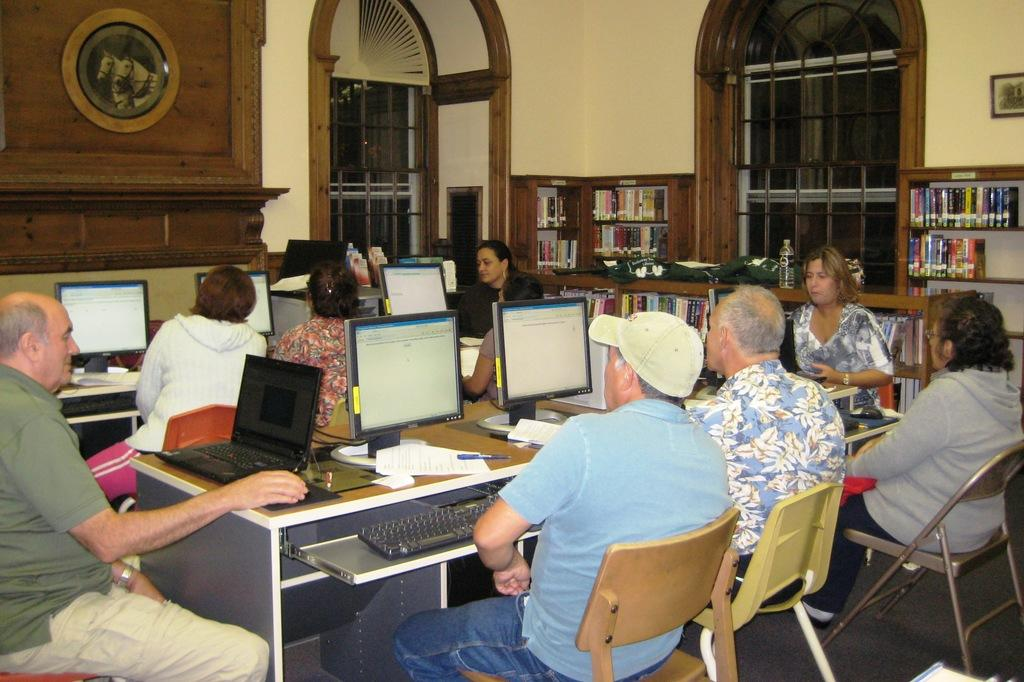What type of structure can be seen in the image? There is a wall in the image. What feature allows light and air into the room? There is a window in the image. What are the people in the image doing? The people are sitting on chairs in the image. What furniture is present in the image? There are tables in the image. What electronic devices can be seen on the tables? There are laptops on the tables. What stationary items are on the tables? There are pens and papers on the tables. How many necks are visible in the image? There is no mention of necks in the image; the focus is on the wall, window, chairs, tables, laptops, pens, and papers. What is the addition to the room that the people are working on? There is no addition or project mentioned in the image; the people are simply sitting on chairs with laptops, pens, and papers on the tables. 